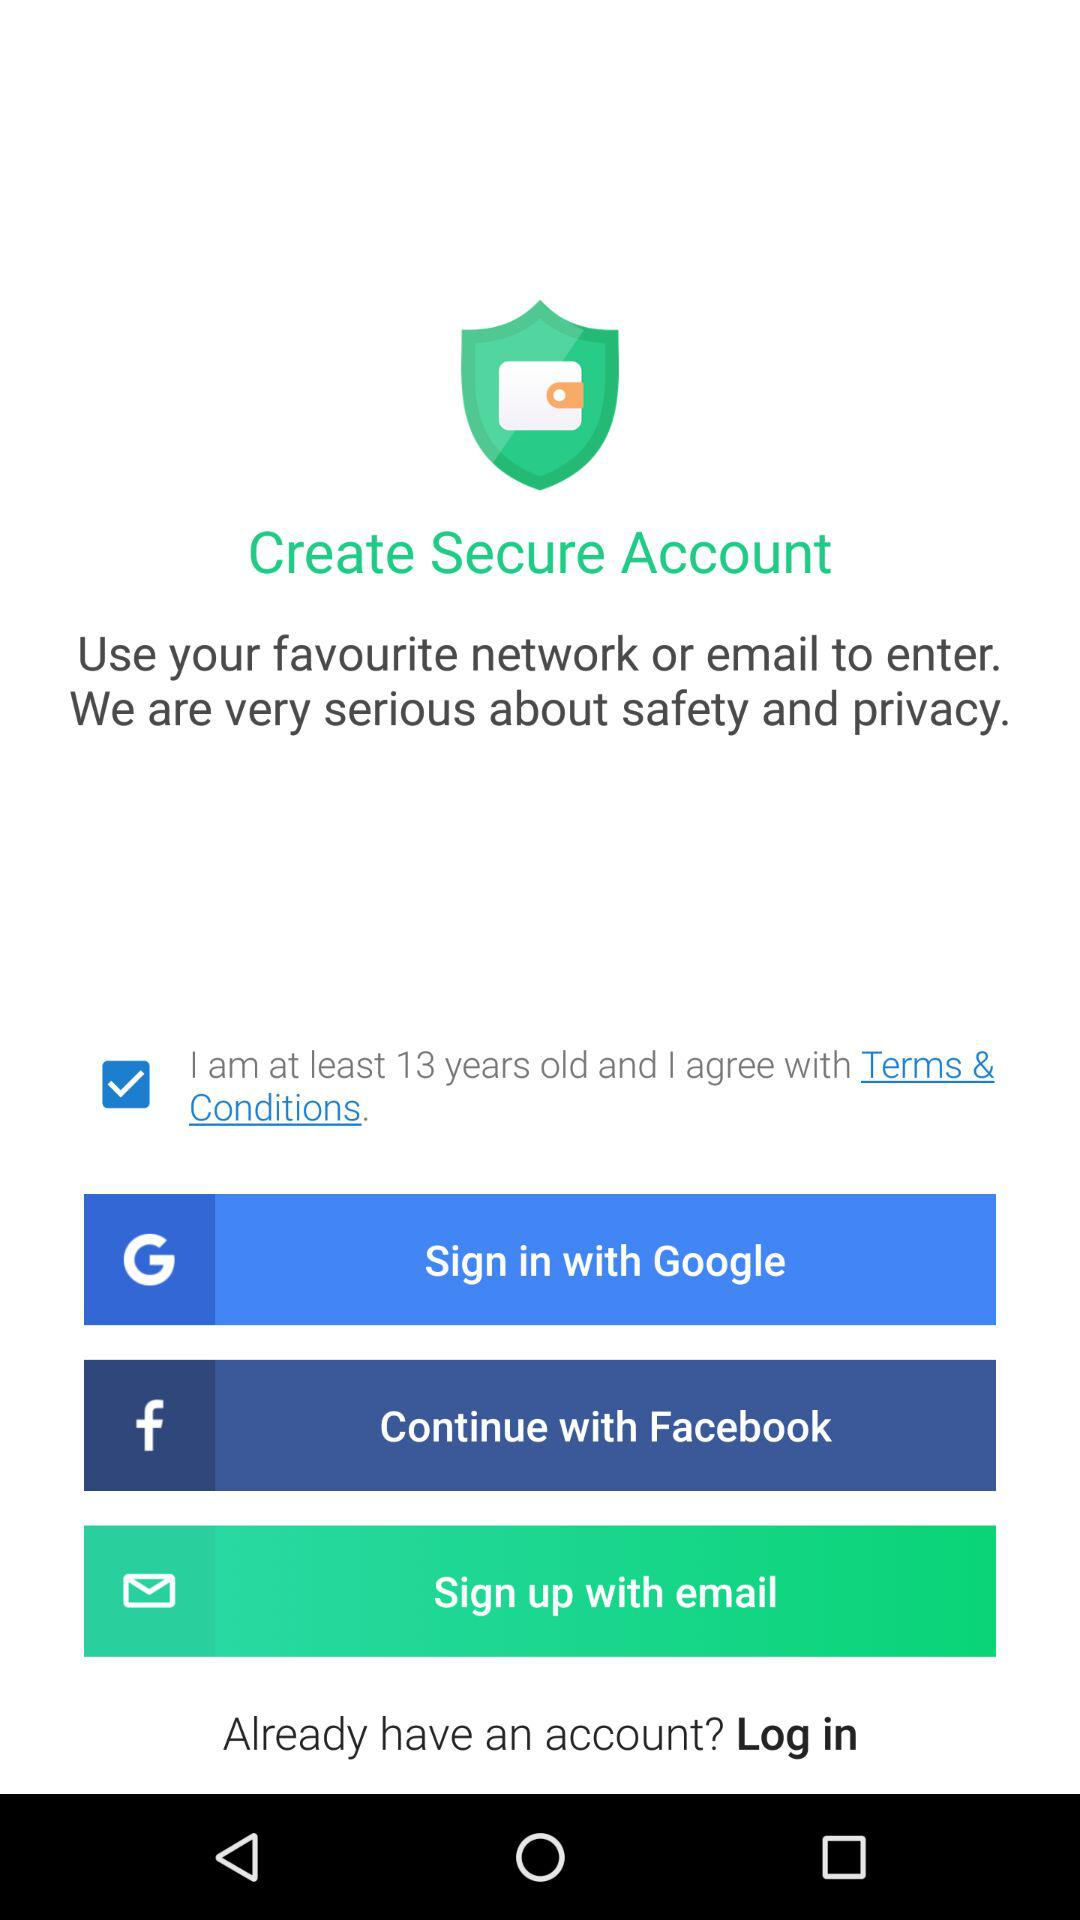What is the mentioned age? The mentioned age is 13 years. 